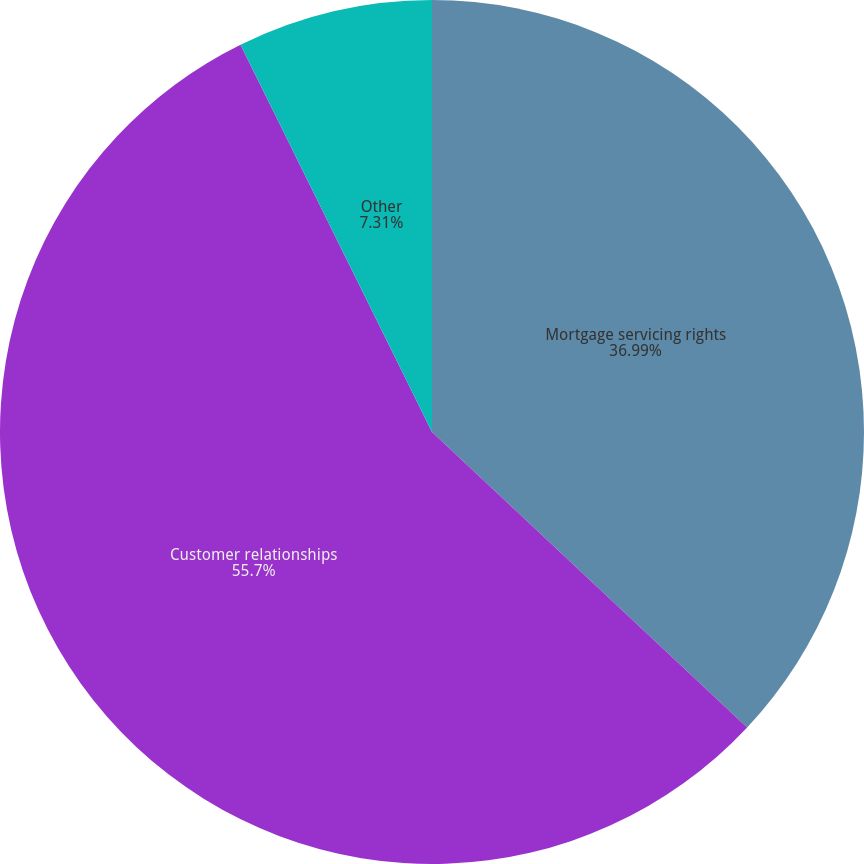Convert chart. <chart><loc_0><loc_0><loc_500><loc_500><pie_chart><fcel>Mortgage servicing rights<fcel>Customer relationships<fcel>Other<nl><fcel>36.99%<fcel>55.71%<fcel>7.31%<nl></chart> 